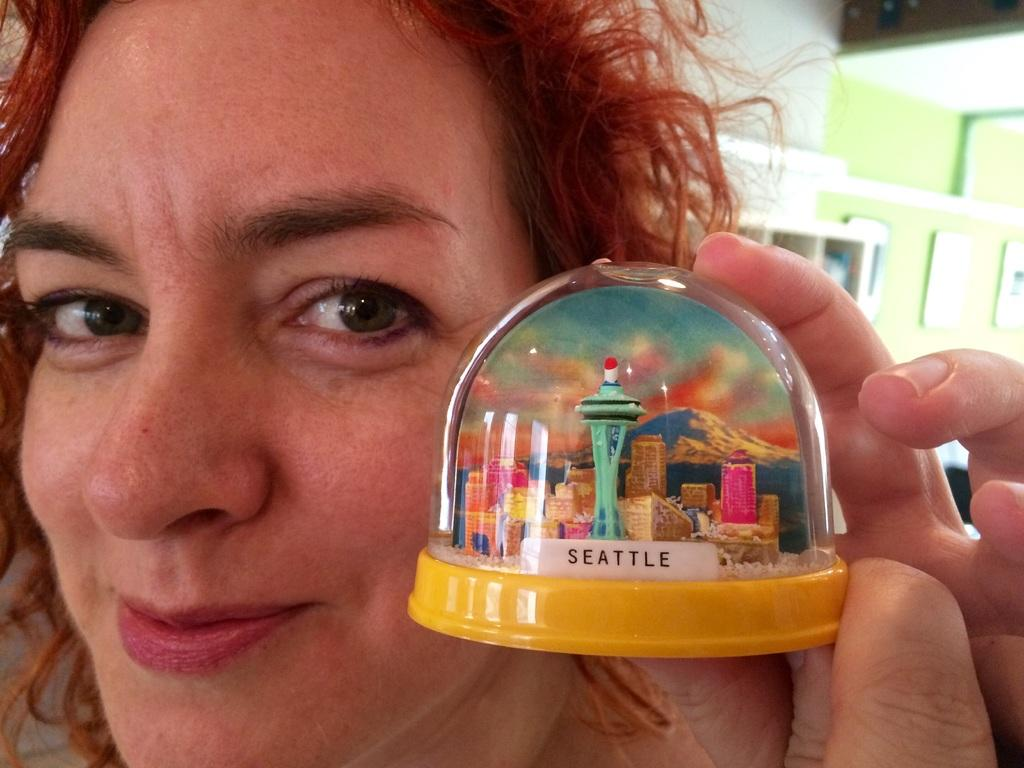<image>
Summarize the visual content of the image. A smirking  woman holds a snow globe containing a mini model of Seattle. 